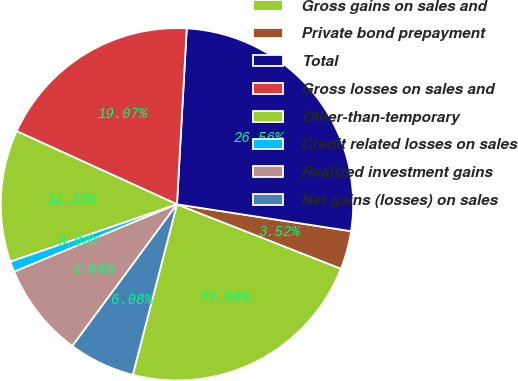Convert chart. <chart><loc_0><loc_0><loc_500><loc_500><pie_chart><fcel>Gross gains on sales and<fcel>Private bond prepayment<fcel>Total<fcel>Gross losses on sales and<fcel>Other-than-temporary<fcel>Credit related losses on sales<fcel>Realized investment gains<fcel>Net gains (losses) on sales<nl><fcel>23.08%<fcel>3.52%<fcel>26.56%<fcel>19.07%<fcel>12.1%<fcel>0.96%<fcel>8.64%<fcel>6.08%<nl></chart> 